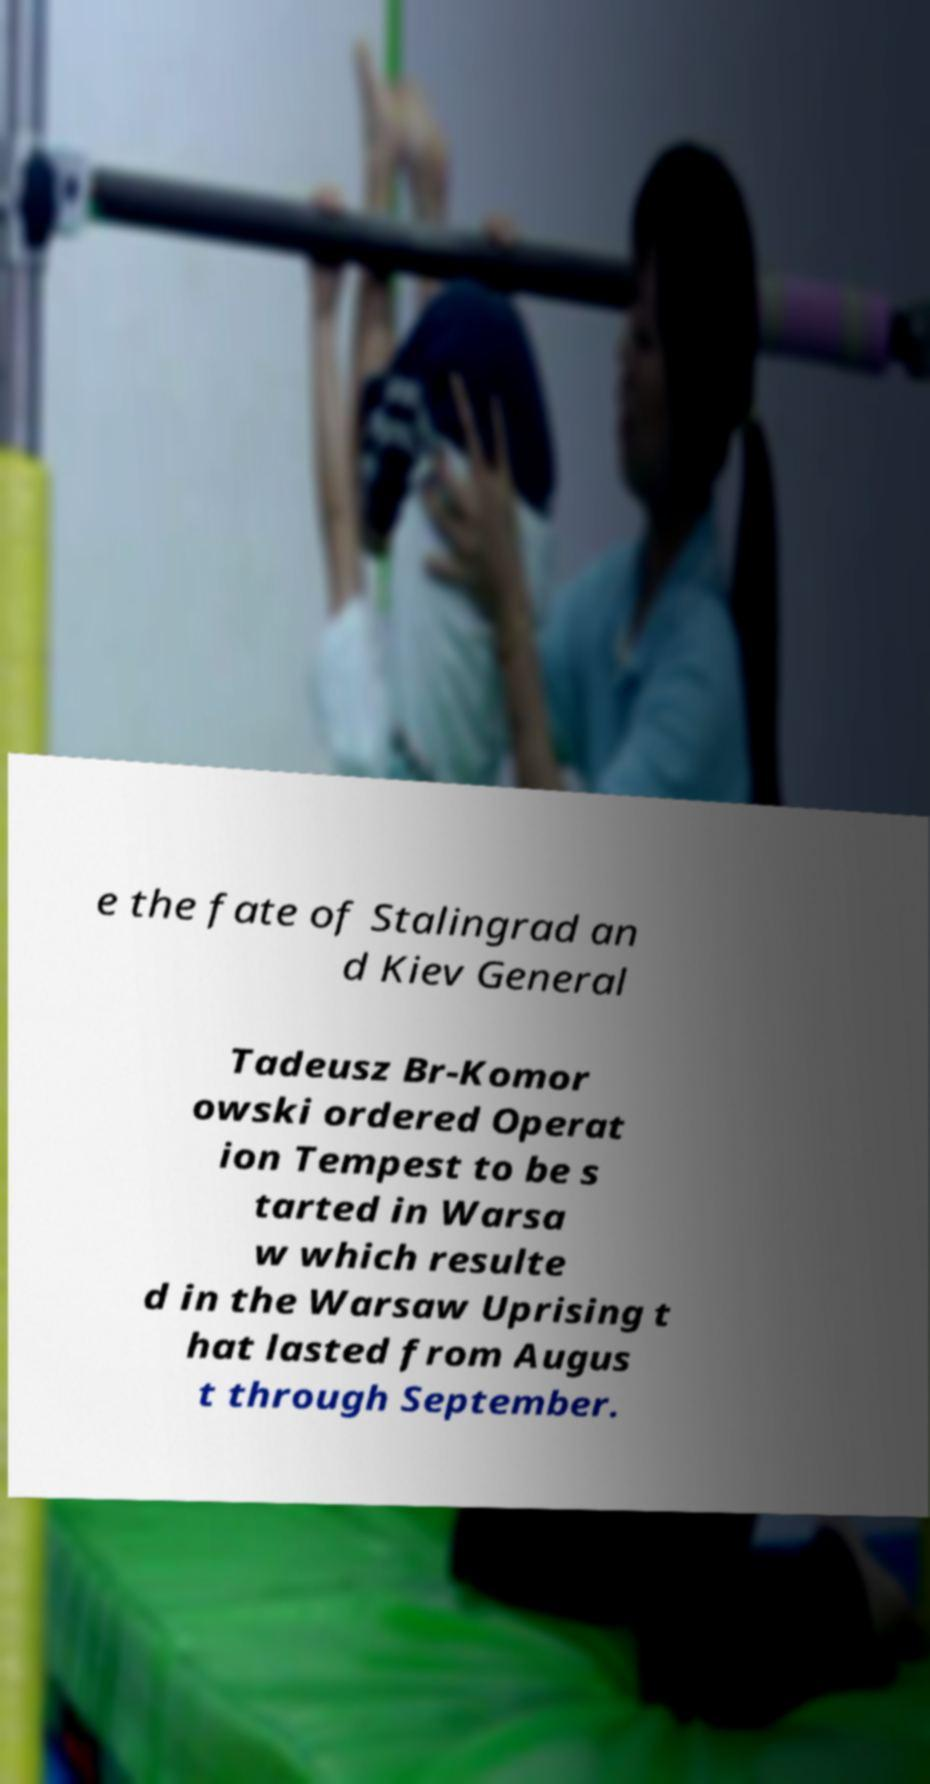I need the written content from this picture converted into text. Can you do that? e the fate of Stalingrad an d Kiev General Tadeusz Br-Komor owski ordered Operat ion Tempest to be s tarted in Warsa w which resulte d in the Warsaw Uprising t hat lasted from Augus t through September. 